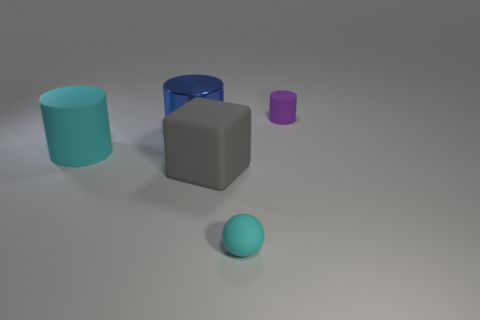There is a small cyan thing that is made of the same material as the large gray object; what is its shape?
Offer a very short reply. Sphere. Do the blue object and the small object left of the small rubber cylinder have the same shape?
Give a very brief answer. No. What is the material of the small object that is in front of the cylinder that is on the right side of the large shiny cylinder?
Ensure brevity in your answer.  Rubber. What number of other objects are there of the same shape as the gray object?
Provide a short and direct response. 0. Do the cyan rubber thing on the right side of the cyan matte cylinder and the large thing that is to the right of the big blue metallic object have the same shape?
Provide a succinct answer. No. Is there anything else that has the same material as the purple cylinder?
Ensure brevity in your answer.  Yes. What is the large gray thing made of?
Your answer should be very brief. Rubber. There is a small thing that is in front of the tiny purple thing; what is it made of?
Keep it short and to the point. Rubber. Is there any other thing of the same color as the matte block?
Your response must be concise. No. The cyan ball that is made of the same material as the tiny purple object is what size?
Offer a very short reply. Small. 